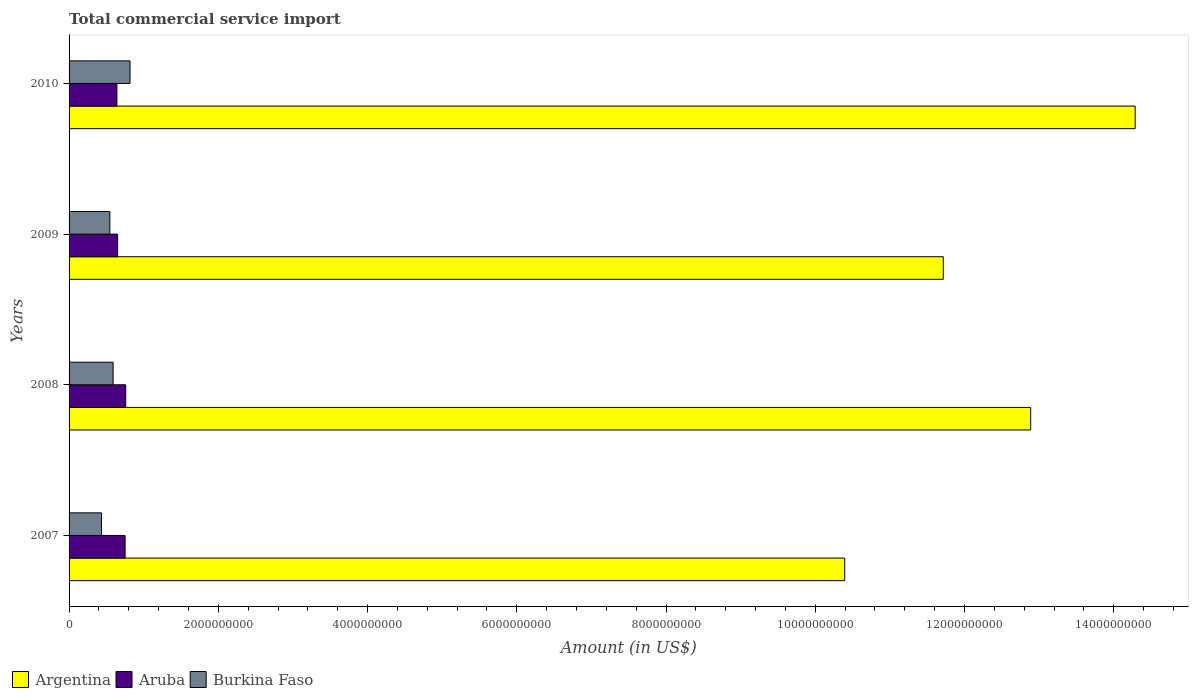Are the number of bars on each tick of the Y-axis equal?
Offer a very short reply. Yes. How many bars are there on the 4th tick from the bottom?
Your answer should be compact. 3. What is the label of the 1st group of bars from the top?
Your response must be concise. 2010. What is the total commercial service import in Argentina in 2009?
Your answer should be very brief. 1.17e+1. Across all years, what is the maximum total commercial service import in Burkina Faso?
Your answer should be compact. 8.17e+08. Across all years, what is the minimum total commercial service import in Argentina?
Give a very brief answer. 1.04e+1. What is the total total commercial service import in Argentina in the graph?
Offer a very short reply. 4.93e+1. What is the difference between the total commercial service import in Aruba in 2008 and that in 2010?
Ensure brevity in your answer.  1.18e+08. What is the difference between the total commercial service import in Burkina Faso in 2010 and the total commercial service import in Argentina in 2008?
Your answer should be compact. -1.21e+1. What is the average total commercial service import in Argentina per year?
Your response must be concise. 1.23e+1. In the year 2009, what is the difference between the total commercial service import in Argentina and total commercial service import in Burkina Faso?
Keep it short and to the point. 1.12e+1. In how many years, is the total commercial service import in Argentina greater than 6800000000 US$?
Provide a succinct answer. 4. What is the ratio of the total commercial service import in Argentina in 2007 to that in 2008?
Offer a very short reply. 0.81. Is the total commercial service import in Burkina Faso in 2007 less than that in 2010?
Your answer should be compact. Yes. What is the difference between the highest and the second highest total commercial service import in Burkina Faso?
Your answer should be compact. 2.27e+08. What is the difference between the highest and the lowest total commercial service import in Burkina Faso?
Your answer should be compact. 3.82e+08. What does the 2nd bar from the top in 2010 represents?
Provide a succinct answer. Aruba. Is it the case that in every year, the sum of the total commercial service import in Burkina Faso and total commercial service import in Aruba is greater than the total commercial service import in Argentina?
Offer a very short reply. No. How many years are there in the graph?
Give a very brief answer. 4. What is the difference between two consecutive major ticks on the X-axis?
Your answer should be compact. 2.00e+09. Does the graph contain any zero values?
Provide a succinct answer. No. What is the title of the graph?
Make the answer very short. Total commercial service import. Does "Brazil" appear as one of the legend labels in the graph?
Your answer should be very brief. No. What is the label or title of the Y-axis?
Provide a succinct answer. Years. What is the Amount (in US$) in Argentina in 2007?
Your answer should be very brief. 1.04e+1. What is the Amount (in US$) in Aruba in 2007?
Give a very brief answer. 7.51e+08. What is the Amount (in US$) of Burkina Faso in 2007?
Ensure brevity in your answer.  4.35e+08. What is the Amount (in US$) of Argentina in 2008?
Provide a succinct answer. 1.29e+1. What is the Amount (in US$) of Aruba in 2008?
Keep it short and to the point. 7.59e+08. What is the Amount (in US$) of Burkina Faso in 2008?
Your response must be concise. 5.90e+08. What is the Amount (in US$) of Argentina in 2009?
Your answer should be compact. 1.17e+1. What is the Amount (in US$) in Aruba in 2009?
Your response must be concise. 6.50e+08. What is the Amount (in US$) in Burkina Faso in 2009?
Ensure brevity in your answer.  5.46e+08. What is the Amount (in US$) of Argentina in 2010?
Keep it short and to the point. 1.43e+1. What is the Amount (in US$) in Aruba in 2010?
Your answer should be very brief. 6.41e+08. What is the Amount (in US$) of Burkina Faso in 2010?
Offer a terse response. 8.17e+08. Across all years, what is the maximum Amount (in US$) of Argentina?
Your answer should be very brief. 1.43e+1. Across all years, what is the maximum Amount (in US$) of Aruba?
Offer a terse response. 7.59e+08. Across all years, what is the maximum Amount (in US$) of Burkina Faso?
Your answer should be very brief. 8.17e+08. Across all years, what is the minimum Amount (in US$) of Argentina?
Offer a very short reply. 1.04e+1. Across all years, what is the minimum Amount (in US$) of Aruba?
Offer a very short reply. 6.41e+08. Across all years, what is the minimum Amount (in US$) of Burkina Faso?
Ensure brevity in your answer.  4.35e+08. What is the total Amount (in US$) in Argentina in the graph?
Provide a succinct answer. 4.93e+1. What is the total Amount (in US$) in Aruba in the graph?
Your answer should be compact. 2.80e+09. What is the total Amount (in US$) in Burkina Faso in the graph?
Your response must be concise. 2.39e+09. What is the difference between the Amount (in US$) in Argentina in 2007 and that in 2008?
Provide a succinct answer. -2.49e+09. What is the difference between the Amount (in US$) of Aruba in 2007 and that in 2008?
Provide a succinct answer. -7.77e+06. What is the difference between the Amount (in US$) of Burkina Faso in 2007 and that in 2008?
Give a very brief answer. -1.56e+08. What is the difference between the Amount (in US$) of Argentina in 2007 and that in 2009?
Your response must be concise. -1.32e+09. What is the difference between the Amount (in US$) in Aruba in 2007 and that in 2009?
Provide a succinct answer. 1.01e+08. What is the difference between the Amount (in US$) in Burkina Faso in 2007 and that in 2009?
Offer a terse response. -1.12e+08. What is the difference between the Amount (in US$) in Argentina in 2007 and that in 2010?
Keep it short and to the point. -3.89e+09. What is the difference between the Amount (in US$) of Aruba in 2007 and that in 2010?
Provide a short and direct response. 1.10e+08. What is the difference between the Amount (in US$) of Burkina Faso in 2007 and that in 2010?
Offer a terse response. -3.82e+08. What is the difference between the Amount (in US$) of Argentina in 2008 and that in 2009?
Your answer should be very brief. 1.17e+09. What is the difference between the Amount (in US$) of Aruba in 2008 and that in 2009?
Keep it short and to the point. 1.08e+08. What is the difference between the Amount (in US$) in Burkina Faso in 2008 and that in 2009?
Your answer should be compact. 4.38e+07. What is the difference between the Amount (in US$) of Argentina in 2008 and that in 2010?
Give a very brief answer. -1.40e+09. What is the difference between the Amount (in US$) in Aruba in 2008 and that in 2010?
Ensure brevity in your answer.  1.18e+08. What is the difference between the Amount (in US$) in Burkina Faso in 2008 and that in 2010?
Keep it short and to the point. -2.27e+08. What is the difference between the Amount (in US$) of Argentina in 2009 and that in 2010?
Your answer should be compact. -2.57e+09. What is the difference between the Amount (in US$) in Aruba in 2009 and that in 2010?
Your answer should be compact. 9.39e+06. What is the difference between the Amount (in US$) in Burkina Faso in 2009 and that in 2010?
Your answer should be very brief. -2.71e+08. What is the difference between the Amount (in US$) in Argentina in 2007 and the Amount (in US$) in Aruba in 2008?
Offer a very short reply. 9.64e+09. What is the difference between the Amount (in US$) of Argentina in 2007 and the Amount (in US$) of Burkina Faso in 2008?
Offer a terse response. 9.80e+09. What is the difference between the Amount (in US$) in Aruba in 2007 and the Amount (in US$) in Burkina Faso in 2008?
Your answer should be compact. 1.61e+08. What is the difference between the Amount (in US$) of Argentina in 2007 and the Amount (in US$) of Aruba in 2009?
Provide a succinct answer. 9.74e+09. What is the difference between the Amount (in US$) in Argentina in 2007 and the Amount (in US$) in Burkina Faso in 2009?
Ensure brevity in your answer.  9.85e+09. What is the difference between the Amount (in US$) in Aruba in 2007 and the Amount (in US$) in Burkina Faso in 2009?
Make the answer very short. 2.05e+08. What is the difference between the Amount (in US$) in Argentina in 2007 and the Amount (in US$) in Aruba in 2010?
Keep it short and to the point. 9.75e+09. What is the difference between the Amount (in US$) in Argentina in 2007 and the Amount (in US$) in Burkina Faso in 2010?
Your answer should be compact. 9.58e+09. What is the difference between the Amount (in US$) in Aruba in 2007 and the Amount (in US$) in Burkina Faso in 2010?
Ensure brevity in your answer.  -6.59e+07. What is the difference between the Amount (in US$) of Argentina in 2008 and the Amount (in US$) of Aruba in 2009?
Ensure brevity in your answer.  1.22e+1. What is the difference between the Amount (in US$) in Argentina in 2008 and the Amount (in US$) in Burkina Faso in 2009?
Give a very brief answer. 1.23e+1. What is the difference between the Amount (in US$) in Aruba in 2008 and the Amount (in US$) in Burkina Faso in 2009?
Ensure brevity in your answer.  2.12e+08. What is the difference between the Amount (in US$) in Argentina in 2008 and the Amount (in US$) in Aruba in 2010?
Your response must be concise. 1.22e+1. What is the difference between the Amount (in US$) of Argentina in 2008 and the Amount (in US$) of Burkina Faso in 2010?
Provide a short and direct response. 1.21e+1. What is the difference between the Amount (in US$) in Aruba in 2008 and the Amount (in US$) in Burkina Faso in 2010?
Keep it short and to the point. -5.82e+07. What is the difference between the Amount (in US$) in Argentina in 2009 and the Amount (in US$) in Aruba in 2010?
Give a very brief answer. 1.11e+1. What is the difference between the Amount (in US$) of Argentina in 2009 and the Amount (in US$) of Burkina Faso in 2010?
Ensure brevity in your answer.  1.09e+1. What is the difference between the Amount (in US$) of Aruba in 2009 and the Amount (in US$) of Burkina Faso in 2010?
Your response must be concise. -1.67e+08. What is the average Amount (in US$) in Argentina per year?
Ensure brevity in your answer.  1.23e+1. What is the average Amount (in US$) of Aruba per year?
Make the answer very short. 7.00e+08. What is the average Amount (in US$) in Burkina Faso per year?
Keep it short and to the point. 5.97e+08. In the year 2007, what is the difference between the Amount (in US$) of Argentina and Amount (in US$) of Aruba?
Provide a succinct answer. 9.64e+09. In the year 2007, what is the difference between the Amount (in US$) of Argentina and Amount (in US$) of Burkina Faso?
Keep it short and to the point. 9.96e+09. In the year 2007, what is the difference between the Amount (in US$) of Aruba and Amount (in US$) of Burkina Faso?
Keep it short and to the point. 3.16e+08. In the year 2008, what is the difference between the Amount (in US$) of Argentina and Amount (in US$) of Aruba?
Offer a terse response. 1.21e+1. In the year 2008, what is the difference between the Amount (in US$) of Argentina and Amount (in US$) of Burkina Faso?
Give a very brief answer. 1.23e+1. In the year 2008, what is the difference between the Amount (in US$) in Aruba and Amount (in US$) in Burkina Faso?
Offer a very short reply. 1.69e+08. In the year 2009, what is the difference between the Amount (in US$) of Argentina and Amount (in US$) of Aruba?
Offer a terse response. 1.11e+1. In the year 2009, what is the difference between the Amount (in US$) in Argentina and Amount (in US$) in Burkina Faso?
Ensure brevity in your answer.  1.12e+1. In the year 2009, what is the difference between the Amount (in US$) in Aruba and Amount (in US$) in Burkina Faso?
Your response must be concise. 1.04e+08. In the year 2010, what is the difference between the Amount (in US$) in Argentina and Amount (in US$) in Aruba?
Your answer should be compact. 1.36e+1. In the year 2010, what is the difference between the Amount (in US$) of Argentina and Amount (in US$) of Burkina Faso?
Your answer should be very brief. 1.35e+1. In the year 2010, what is the difference between the Amount (in US$) of Aruba and Amount (in US$) of Burkina Faso?
Keep it short and to the point. -1.76e+08. What is the ratio of the Amount (in US$) in Argentina in 2007 to that in 2008?
Ensure brevity in your answer.  0.81. What is the ratio of the Amount (in US$) of Aruba in 2007 to that in 2008?
Offer a very short reply. 0.99. What is the ratio of the Amount (in US$) of Burkina Faso in 2007 to that in 2008?
Offer a terse response. 0.74. What is the ratio of the Amount (in US$) of Argentina in 2007 to that in 2009?
Give a very brief answer. 0.89. What is the ratio of the Amount (in US$) of Aruba in 2007 to that in 2009?
Provide a succinct answer. 1.15. What is the ratio of the Amount (in US$) in Burkina Faso in 2007 to that in 2009?
Your response must be concise. 0.8. What is the ratio of the Amount (in US$) of Argentina in 2007 to that in 2010?
Offer a terse response. 0.73. What is the ratio of the Amount (in US$) in Aruba in 2007 to that in 2010?
Give a very brief answer. 1.17. What is the ratio of the Amount (in US$) of Burkina Faso in 2007 to that in 2010?
Provide a short and direct response. 0.53. What is the ratio of the Amount (in US$) in Argentina in 2008 to that in 2009?
Ensure brevity in your answer.  1.1. What is the ratio of the Amount (in US$) of Burkina Faso in 2008 to that in 2009?
Make the answer very short. 1.08. What is the ratio of the Amount (in US$) of Argentina in 2008 to that in 2010?
Provide a succinct answer. 0.9. What is the ratio of the Amount (in US$) of Aruba in 2008 to that in 2010?
Ensure brevity in your answer.  1.18. What is the ratio of the Amount (in US$) of Burkina Faso in 2008 to that in 2010?
Ensure brevity in your answer.  0.72. What is the ratio of the Amount (in US$) in Argentina in 2009 to that in 2010?
Make the answer very short. 0.82. What is the ratio of the Amount (in US$) in Aruba in 2009 to that in 2010?
Provide a succinct answer. 1.01. What is the ratio of the Amount (in US$) in Burkina Faso in 2009 to that in 2010?
Ensure brevity in your answer.  0.67. What is the difference between the highest and the second highest Amount (in US$) in Argentina?
Offer a terse response. 1.40e+09. What is the difference between the highest and the second highest Amount (in US$) of Aruba?
Provide a short and direct response. 7.77e+06. What is the difference between the highest and the second highest Amount (in US$) in Burkina Faso?
Your answer should be very brief. 2.27e+08. What is the difference between the highest and the lowest Amount (in US$) of Argentina?
Offer a very short reply. 3.89e+09. What is the difference between the highest and the lowest Amount (in US$) in Aruba?
Offer a terse response. 1.18e+08. What is the difference between the highest and the lowest Amount (in US$) of Burkina Faso?
Your answer should be very brief. 3.82e+08. 